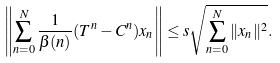Convert formula to latex. <formula><loc_0><loc_0><loc_500><loc_500>\left \| \sum _ { n = 0 } ^ { N } \frac { 1 } { \beta ( n ) } ( T ^ { n } - C ^ { n } ) x _ { n } \right \| \leq s \sqrt { \sum _ { n = 0 } ^ { N } \| x _ { n } \| ^ { 2 } } .</formula> 